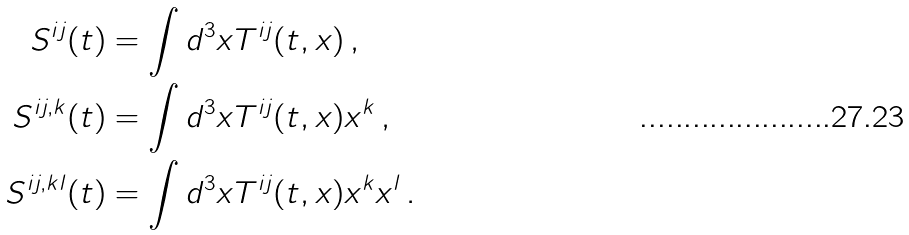Convert formula to latex. <formula><loc_0><loc_0><loc_500><loc_500>S ^ { i j } ( t ) & = \int d ^ { 3 } x T ^ { i j } ( t , x ) \, , \\ S ^ { i j , k } ( t ) & = \int d ^ { 3 } x T ^ { i j } ( t , x ) x ^ { k } \, , \\ S ^ { i j , k l } ( t ) & = \int d ^ { 3 } x T ^ { i j } ( t , x ) x ^ { k } x ^ { l } \, .</formula> 